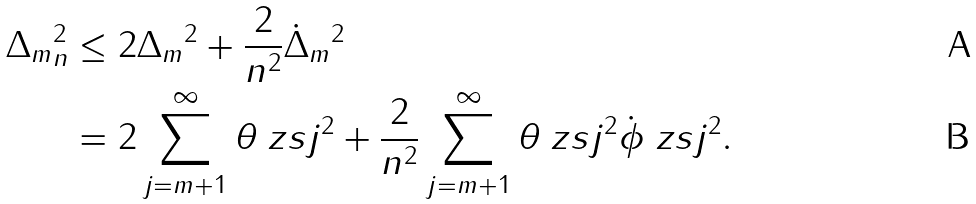Convert formula to latex. <formula><loc_0><loc_0><loc_500><loc_500>\| \Delta _ { m } \| _ { n } ^ { 2 } & \leq 2 \| \Delta _ { m } \| ^ { 2 } + \frac { 2 } { n ^ { 2 } } \| \dot { \Delta } _ { m } \| ^ { 2 } \\ & = 2 \sum _ { j = m + 1 } ^ { \infty } \theta _ { \ } z s { j } ^ { 2 } + \frac { 2 } { n ^ { 2 } } \sum _ { j = m + 1 } ^ { \infty } \theta _ { \ } z s { j } ^ { 2 } \| \dot { \phi } _ { \ } z s { j } \| ^ { 2 } .</formula> 